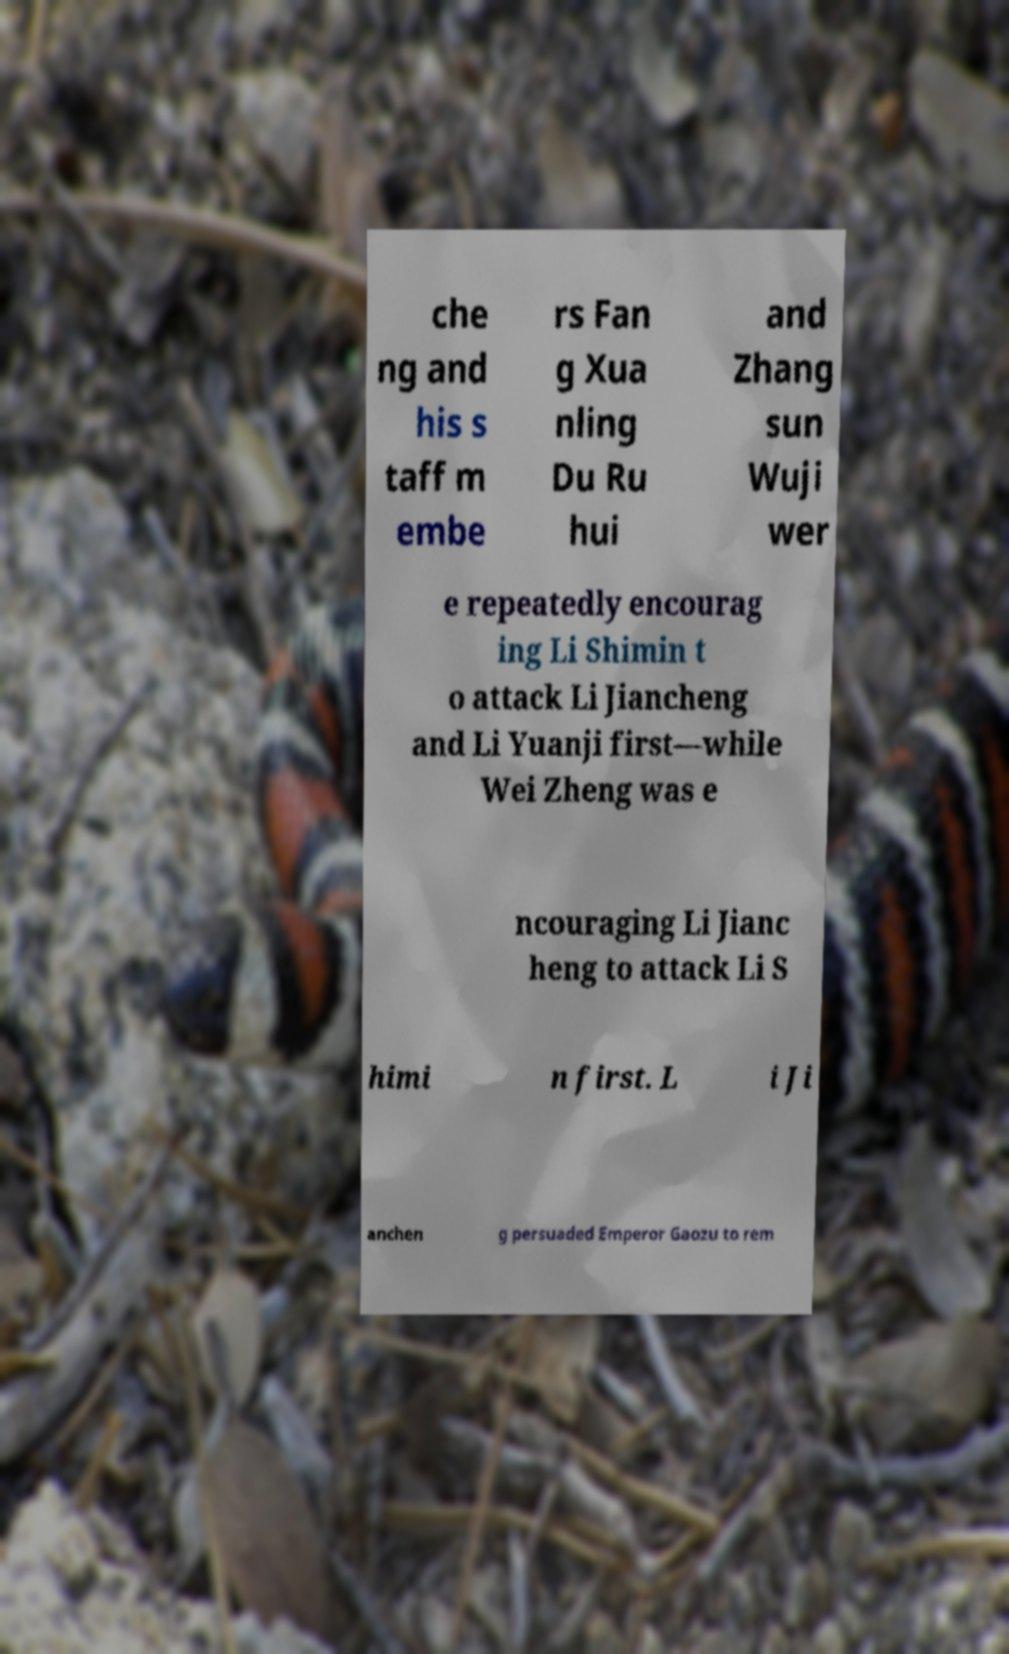Can you read and provide the text displayed in the image?This photo seems to have some interesting text. Can you extract and type it out for me? che ng and his s taff m embe rs Fan g Xua nling Du Ru hui and Zhang sun Wuji wer e repeatedly encourag ing Li Shimin t o attack Li Jiancheng and Li Yuanji first—while Wei Zheng was e ncouraging Li Jianc heng to attack Li S himi n first. L i Ji anchen g persuaded Emperor Gaozu to rem 